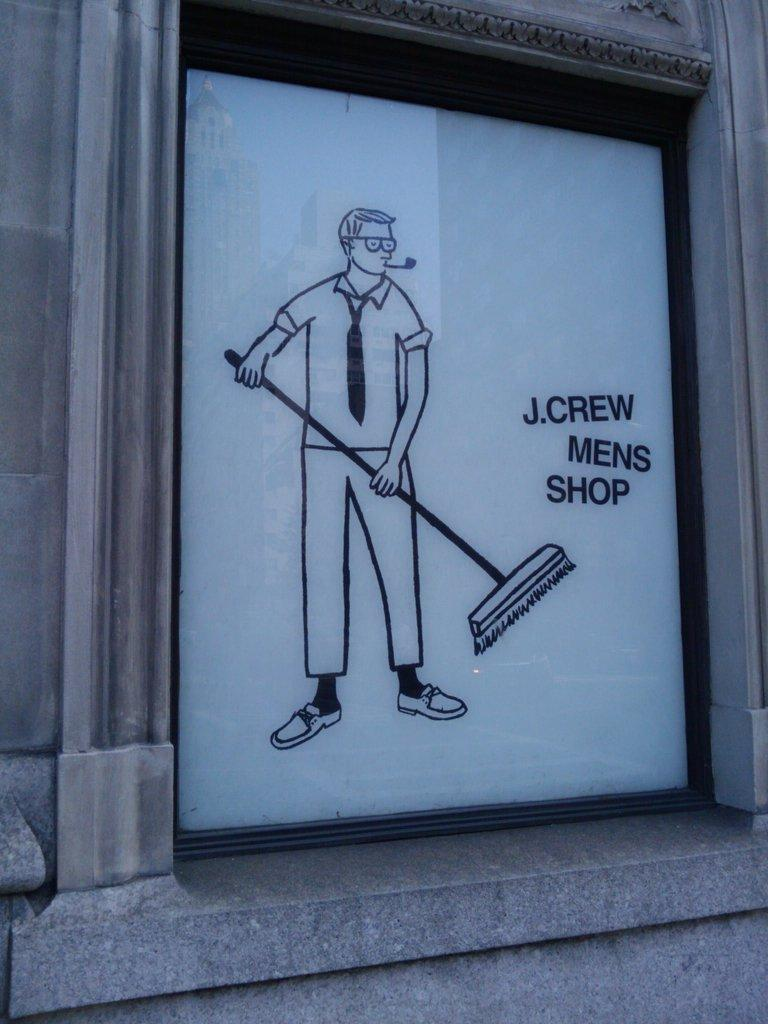What is on the wall in the image? There is a painting on the wall in the image. What is the subject of the painting? The painting depicts a man. What is the man holding in the painting? The man is holding a broomstick in the painting. What type of doctor is depicted in the painting? There is no doctor depicted in the painting; it features a man holding a broomstick. Can you tell me how many volleyballs are visible in the painting? There are no volleyballs present in the painting; it only features a man holding a broomstick. 